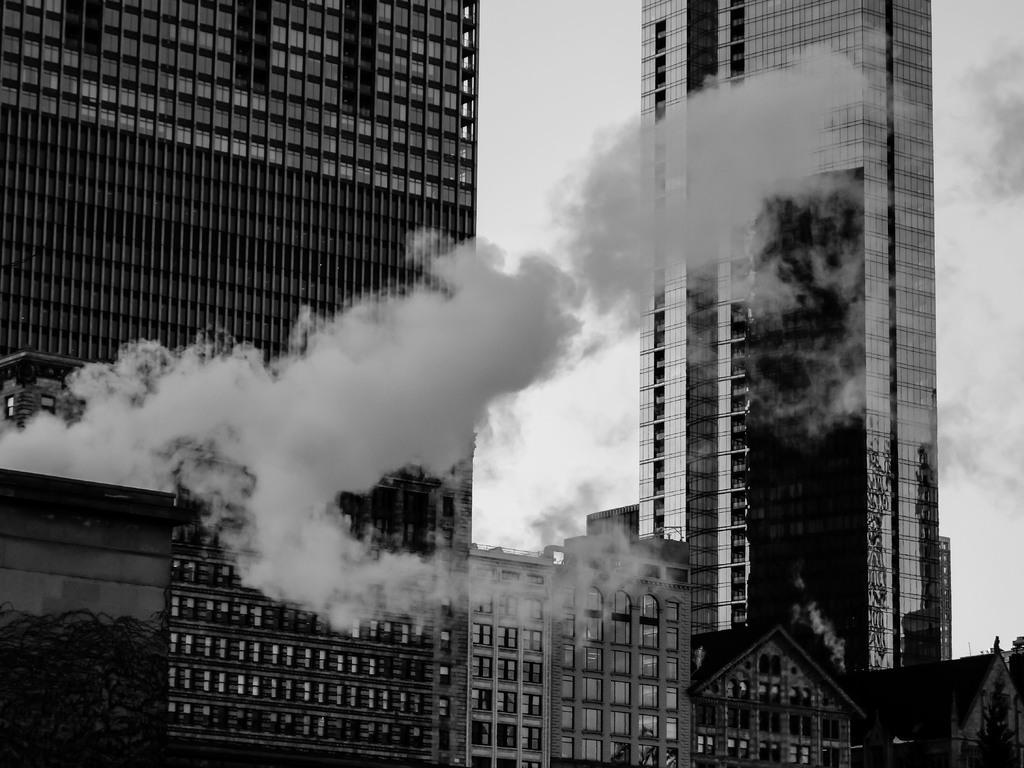How would you summarize this image in a sentence or two? In the image we can see some buildings and air pollution. Behind the building there are some clouds in the sky. 